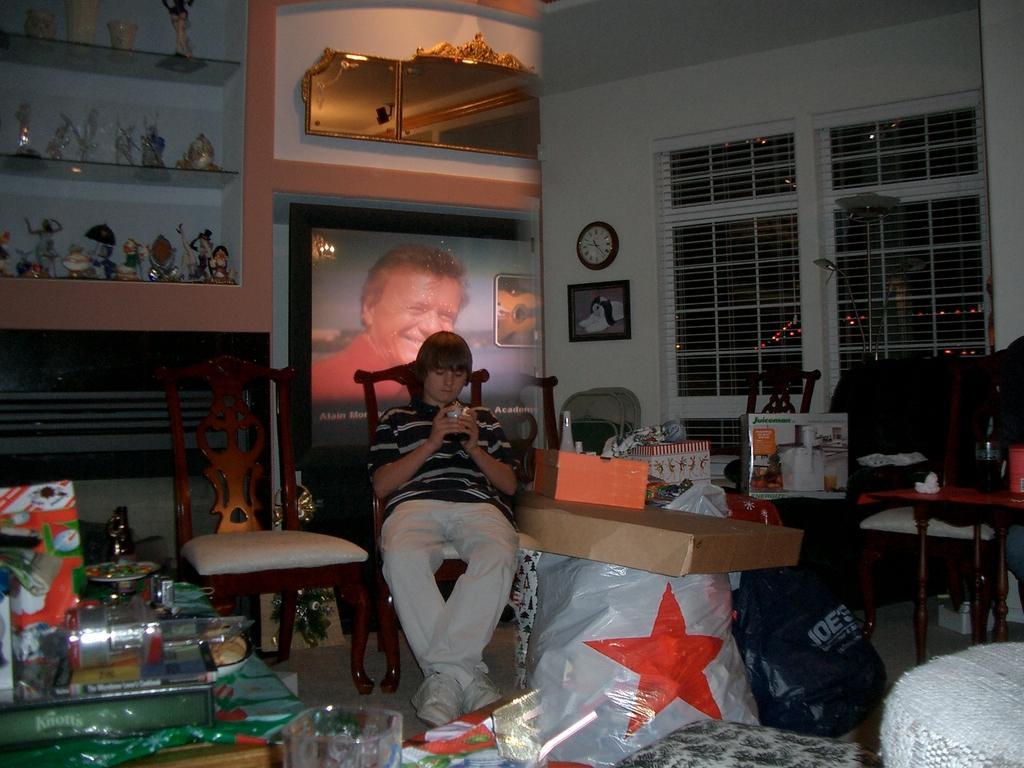Can you describe this image briefly? At the center of the image there is a boy, who is sitting on the chair and holds a mobile. At back side there is a projector which shows a person wearing a red shirt and a guitar. There is a clock and photo-frame attached to the wall, besides its there is a window. On the table there is a bottle and a box. There is a plastic bags on the floor. On left side there is a plate. On the top left there is a shelves which having many toys. 